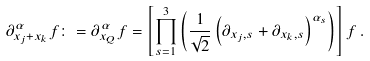<formula> <loc_0><loc_0><loc_500><loc_500>\partial _ { x _ { j } + x _ { k } } ^ { \alpha } f \colon = \partial _ { x _ { Q } } ^ { \alpha } f = \left [ \prod _ { s = 1 } ^ { 3 } \left ( \frac { 1 } { \sqrt { 2 } } \left ( \partial _ { x _ { j } , s } + \partial _ { x _ { k } , s } \right ) ^ { \alpha _ { s } } \right ) \right ] f \, .</formula> 